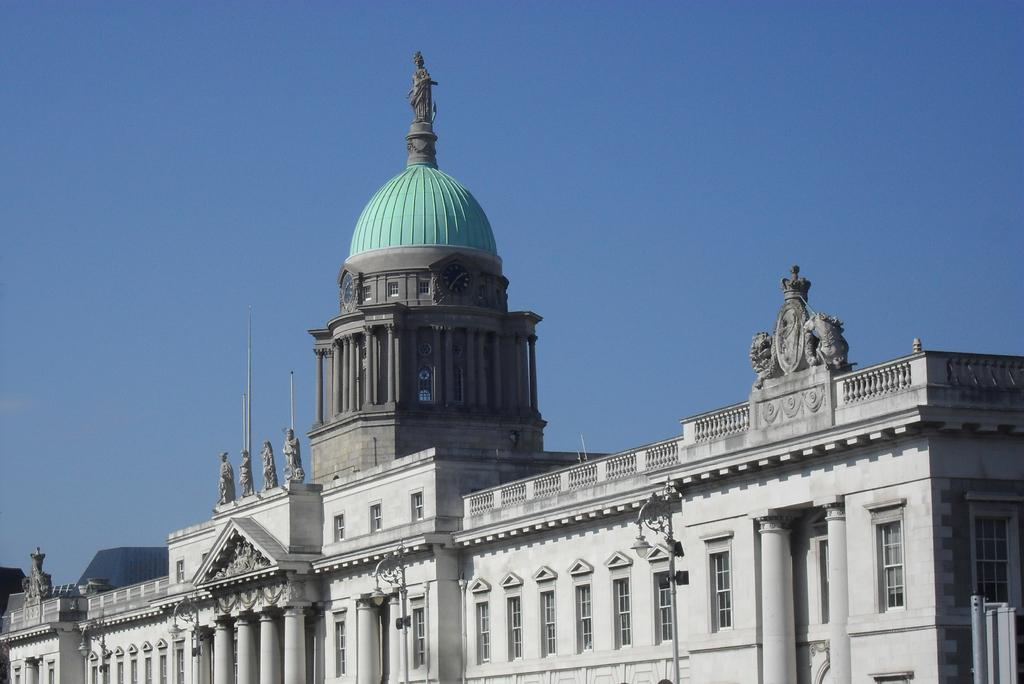What type of establishment is depicted in the image? The image appears to depict a museum. What can be seen on top of the museum? There is a statue on top of the museum. What is visible in the background of the image? The sky is visible in the background of the image. What type of list can be seen hanging on the wall inside the museum? There is no list visible in the image, as it only shows the exterior of the museum with a statue on top and the sky in the background. 